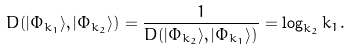<formula> <loc_0><loc_0><loc_500><loc_500>D ( | \Phi _ { k _ { 1 } } \rangle , | \Phi _ { k _ { 2 } } \rangle ) = \frac { 1 } { D ( | \Phi _ { k _ { 2 } } \rangle , | \Phi _ { k _ { 1 } } \rangle ) } = \log _ { k _ { 2 } } k _ { 1 } .</formula> 